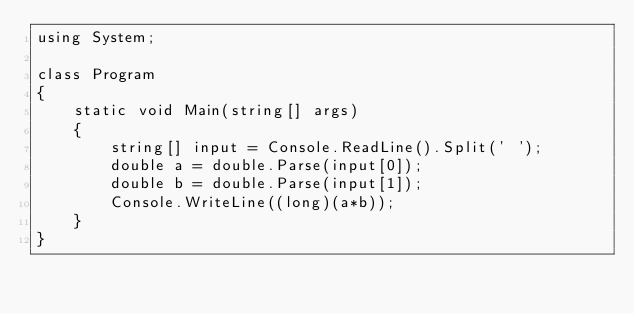<code> <loc_0><loc_0><loc_500><loc_500><_C#_>using System;

class Program
{
    static void Main(string[] args)
    {
        string[] input = Console.ReadLine().Split(' ');
        double a = double.Parse(input[0]);
        double b = double.Parse(input[1]);
        Console.WriteLine((long)(a*b));
    }
}</code> 